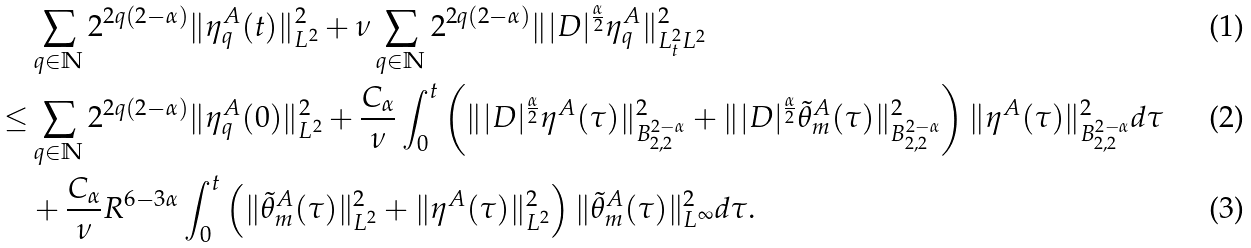<formula> <loc_0><loc_0><loc_500><loc_500>& \sum _ { q \in \mathbb { N } } 2 ^ { 2 q ( 2 - \alpha ) } \| \eta ^ { A } _ { q } ( t ) \| ^ { 2 } _ { L ^ { 2 } } + \nu \sum _ { q \in \mathbb { N } } 2 ^ { 2 q ( 2 - \alpha ) } \| | D | ^ { \frac { \alpha } { 2 } } \eta ^ { A } _ { q } \| _ { L ^ { 2 } _ { t } L ^ { 2 } } ^ { 2 } \\ \leq & \sum _ { q \in \mathbb { N } } 2 ^ { 2 q ( 2 - \alpha ) } \| \eta ^ { A } _ { q } ( 0 ) \| ^ { 2 } _ { L ^ { 2 } } + \frac { C _ { \alpha } } { \nu } \int _ { 0 } ^ { t } \left ( \| | D | ^ { \frac { \alpha } { 2 } } \eta ^ { A } ( \tau ) \| ^ { 2 } _ { B ^ { 2 - \alpha } _ { 2 , 2 } } + \| | D | ^ { \frac { \alpha } { 2 } } \tilde { \theta } ^ { A } _ { m } ( \tau ) \| ^ { 2 } _ { B ^ { 2 - \alpha } _ { 2 , 2 } } \right ) \| \eta ^ { A } ( \tau ) \| ^ { 2 } _ { B ^ { 2 - \alpha } _ { 2 , 2 } } d \tau \\ & + \frac { C _ { \alpha } } { \nu } R ^ { 6 - 3 \alpha } \int _ { 0 } ^ { t } \left ( \| \tilde { \theta } _ { m } ^ { A } ( \tau ) \| _ { L ^ { 2 } } ^ { 2 } + \| \eta ^ { A } ( \tau ) \| _ { L ^ { 2 } } ^ { 2 } \right ) \| \tilde { \theta } ^ { A } _ { m } ( \tau ) \| _ { L ^ { \infty } } ^ { 2 } d \tau .</formula> 